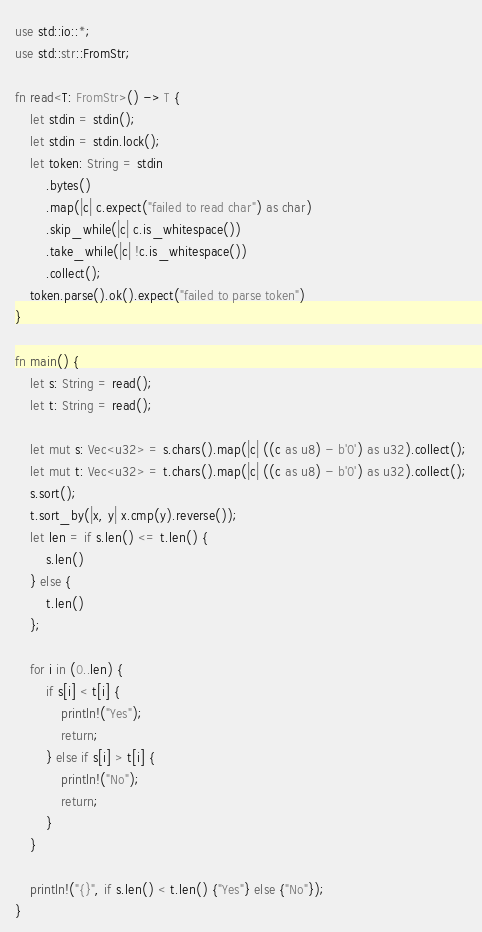<code> <loc_0><loc_0><loc_500><loc_500><_Rust_>use std::io::*;
use std::str::FromStr;

fn read<T: FromStr>() -> T {
    let stdin = stdin();
    let stdin = stdin.lock();
    let token: String = stdin
        .bytes()
        .map(|c| c.expect("failed to read char") as char) 
        .skip_while(|c| c.is_whitespace())
        .take_while(|c| !c.is_whitespace())
        .collect();
    token.parse().ok().expect("failed to parse token")
}

fn main() {
    let s: String = read();
    let t: String = read();

    let mut s: Vec<u32> = s.chars().map(|c| ((c as u8) - b'0') as u32).collect();
    let mut t: Vec<u32> = t.chars().map(|c| ((c as u8) - b'0') as u32).collect();
    s.sort();
    t.sort_by(|x, y| x.cmp(y).reverse());
    let len = if s.len() <= t.len() {
        s.len()
    } else {
        t.len()
    };
    
    for i in (0..len) {
        if s[i] < t[i] {
            println!("Yes");
            return;
        } else if s[i] > t[i] {
            println!("No");
            return;
        }
    }

    println!("{}", if s.len() < t.len() {"Yes"} else {"No"});
}
</code> 